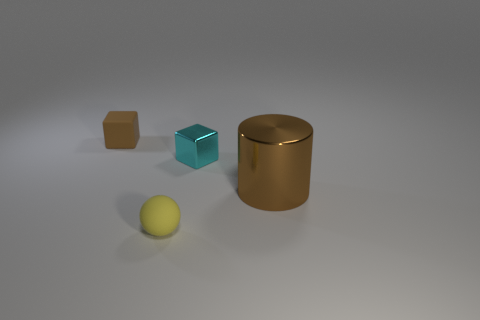What size is the other matte object that is the same color as the big object? The other matte object that shares the same color as the large cylindrical object is small, considerably smaller than the main object, but larger than the spherical object and similar in size to the cube-shaped one. 